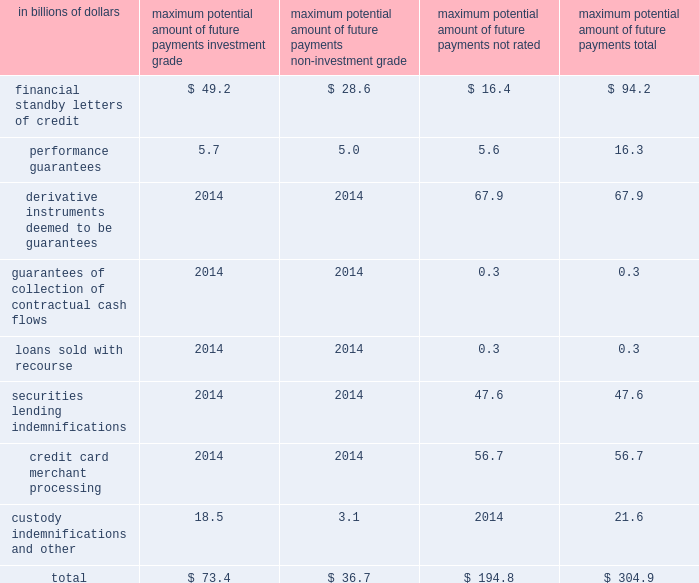Billion at december 31 , 2008 and december 31 , 2007 , respectively .
Securities and other marketable assets held as collateral amounted to $ 27 billion and $ 54 billion , the majority of which collateral is held to reimburse losses realized under securities lending indemnifications .
The decrease from the prior year is in line with the decrease in the notional amount of these indemnifications , which are collateralized .
Additionally , letters of credit in favor of the company held as collateral amounted to $ 503 million and $ 370 million at december 31 , 2008 and december 31 , 2007 , respectively .
Other property may also be available to the company to cover losses under certain guarantees and indemnifications ; however , the value of such property has not been determined .
Performance risk citigroup evaluates the performance risk of its guarantees based on the assigned referenced counterparty internal or external ratings .
Where external ratings are used , investment-grade ratings are considered to be baa/bbb and above , while anything below is considered non-investment grade .
The citigroup internal ratings are in line with the related external rating system .
On certain underlying referenced credits or entities , ratings are not available .
Such referenced credits are included in the 201cnot-rated 201d category .
The maximum potential amount of the future payments related to guarantees and credit derivatives sold is determined to be the notional amount of these contracts , which is the par amount of the assets guaranteed .
Presented in the table below is the maximum potential amount of future payments classified based upon internal and external credit ratings as of december 31 , 2008 .
As previously mentioned , the determination of the maximum potential future payments is based on the notional amount of the guarantees without consideration of possible recoveries under recourse provisions or from collateral held or pledged .
Such amounts bear no relationship to the anticipated losses , if any , on these guarantees. .
Credit derivatives a credit derivative is a bilateral contract between a buyer and a seller under which the seller sells protection against the credit risk of a particular entity ( 201creference entity 201d or 201creference credit 201d ) .
Credit derivatives generally require that the seller of credit protection make payments to the buyer upon the occurrence of predefined credit events ( commonly referred to as 201csettlement triggers 201d ) .
These settlement triggers are defined by the form of the derivative and the reference credit and are generally limited to the market standard of failure to pay on indebtedness and bankruptcy of the reference credit and , in a more limited range of transactions , debt restructuring .
Credit derivative transactions referring to emerging market reference credits will also typically include additional settlement triggers to cover the acceleration of indebtedness and the risk of repudiation or a payment moratorium .
In certain transactions , protection may be provided on a portfolio of referenced credits or asset-backed securities .
The seller of such protection may not be required to make payment until a specified amount of losses has occurred with respect to the portfolio and/or may only be required to pay for losses up to a specified amount .
The company makes markets in and trades a range of credit derivatives , both on behalf of clients as well as for its own account .
Through these contracts , the company either purchases or writes protection on either a single name or a portfolio of reference credits .
The company uses credit derivatives to help mitigate credit risk in its corporate loan portfolio and other cash positions , to take proprietary trading positions , and to facilitate client transactions .
The range of credit derivatives sold includes credit default swaps , total return swaps and credit options .
A credit default swap is a contract in which , for a fee , a protection seller ( guarantor ) agrees to reimburse a protection buyer ( beneficiary ) for any losses that occur due to a credit event on a reference entity .
If there is no credit default event or settlement trigger , as defined by the specific derivative contract , then the guarantor makes no payments to the beneficiary and receives only the contractually specified fee .
However , if a credit event occurs and in accordance with the specific derivative contract sold , the guarantor will be required to make a payment to the beneficiary .
A total return swap transfers the total economic performance of a reference asset , which includes all associated cash flows , as well as capital appreciation or depreciation .
The protection buyer ( beneficiary ) receives a floating rate of interest and any depreciation on the reference asset from the protection seller ( guarantor ) , and in return the protection seller receives the cash flows associated with the reference asset , plus any appreciation .
Thus , the beneficiary will be obligated to make a payment any time the floating interest rate payment according to the total return swap agreement and any depreciation of the reference asset exceed the cash flows associated with the underlying asset .
A total return swap may terminate upon a default of the reference asset subject to the provisions in the related total return swap agreement between the protection seller ( guarantor ) and the protection buyer ( beneficiary ) . .
What percent of total maximum potential amount of future payments are backed by letters of credit ? \\n? 
Computations: (94.2 / 304.9)
Answer: 0.30895. 